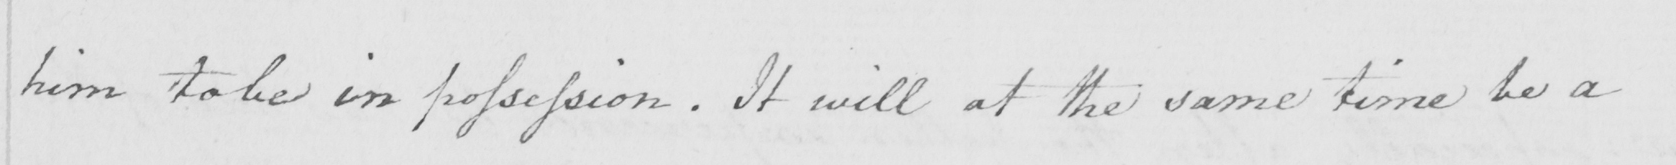What text is written in this handwritten line? him to be in possession . It will at the same time be a 